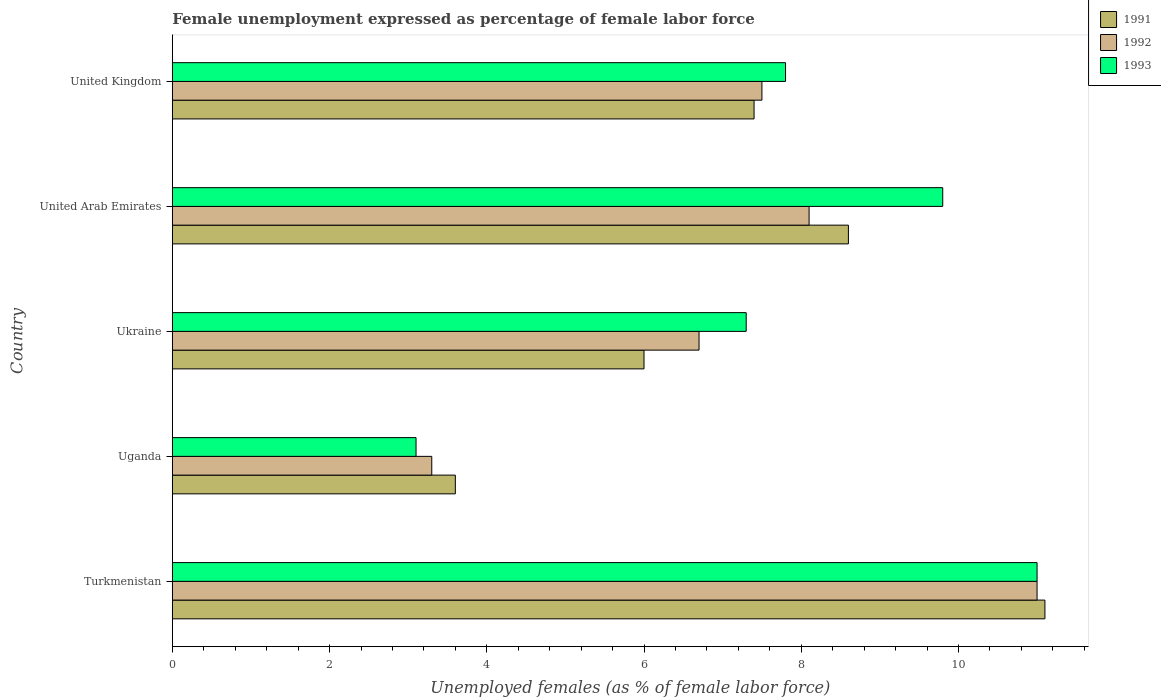How many different coloured bars are there?
Offer a terse response. 3. How many groups of bars are there?
Give a very brief answer. 5. Are the number of bars per tick equal to the number of legend labels?
Give a very brief answer. Yes. How many bars are there on the 5th tick from the top?
Keep it short and to the point. 3. How many bars are there on the 3rd tick from the bottom?
Provide a short and direct response. 3. What is the label of the 5th group of bars from the top?
Offer a terse response. Turkmenistan. In how many cases, is the number of bars for a given country not equal to the number of legend labels?
Keep it short and to the point. 0. What is the unemployment in females in in 1993 in Uganda?
Your answer should be very brief. 3.1. Across all countries, what is the maximum unemployment in females in in 1992?
Your answer should be compact. 11. Across all countries, what is the minimum unemployment in females in in 1992?
Provide a short and direct response. 3.3. In which country was the unemployment in females in in 1991 maximum?
Your answer should be compact. Turkmenistan. In which country was the unemployment in females in in 1993 minimum?
Provide a succinct answer. Uganda. What is the total unemployment in females in in 1992 in the graph?
Keep it short and to the point. 36.6. What is the difference between the unemployment in females in in 1991 in Uganda and that in United Kingdom?
Keep it short and to the point. -3.8. What is the difference between the unemployment in females in in 1993 in Uganda and the unemployment in females in in 1992 in Turkmenistan?
Offer a very short reply. -7.9. What is the average unemployment in females in in 1992 per country?
Offer a terse response. 7.32. What is the difference between the unemployment in females in in 1993 and unemployment in females in in 1992 in United Kingdom?
Your answer should be very brief. 0.3. What is the ratio of the unemployment in females in in 1993 in Uganda to that in United Kingdom?
Keep it short and to the point. 0.4. Is the unemployment in females in in 1991 in United Arab Emirates less than that in United Kingdom?
Your response must be concise. No. Is the difference between the unemployment in females in in 1993 in United Arab Emirates and United Kingdom greater than the difference between the unemployment in females in in 1992 in United Arab Emirates and United Kingdom?
Make the answer very short. Yes. What is the difference between the highest and the second highest unemployment in females in in 1991?
Offer a terse response. 2.5. What is the difference between the highest and the lowest unemployment in females in in 1993?
Your answer should be very brief. 7.9. Is the sum of the unemployment in females in in 1992 in Uganda and United Arab Emirates greater than the maximum unemployment in females in in 1991 across all countries?
Offer a terse response. Yes. What does the 1st bar from the bottom in Turkmenistan represents?
Your answer should be very brief. 1991. Is it the case that in every country, the sum of the unemployment in females in in 1993 and unemployment in females in in 1992 is greater than the unemployment in females in in 1991?
Your answer should be very brief. Yes. How many bars are there?
Make the answer very short. 15. How many countries are there in the graph?
Ensure brevity in your answer.  5. What is the difference between two consecutive major ticks on the X-axis?
Your response must be concise. 2. Are the values on the major ticks of X-axis written in scientific E-notation?
Provide a short and direct response. No. Does the graph contain any zero values?
Provide a succinct answer. No. What is the title of the graph?
Offer a terse response. Female unemployment expressed as percentage of female labor force. Does "1986" appear as one of the legend labels in the graph?
Offer a terse response. No. What is the label or title of the X-axis?
Your response must be concise. Unemployed females (as % of female labor force). What is the label or title of the Y-axis?
Ensure brevity in your answer.  Country. What is the Unemployed females (as % of female labor force) in 1991 in Turkmenistan?
Offer a very short reply. 11.1. What is the Unemployed females (as % of female labor force) in 1991 in Uganda?
Offer a very short reply. 3.6. What is the Unemployed females (as % of female labor force) of 1992 in Uganda?
Keep it short and to the point. 3.3. What is the Unemployed females (as % of female labor force) of 1993 in Uganda?
Make the answer very short. 3.1. What is the Unemployed females (as % of female labor force) of 1991 in Ukraine?
Ensure brevity in your answer.  6. What is the Unemployed females (as % of female labor force) of 1992 in Ukraine?
Provide a short and direct response. 6.7. What is the Unemployed females (as % of female labor force) in 1993 in Ukraine?
Offer a very short reply. 7.3. What is the Unemployed females (as % of female labor force) in 1991 in United Arab Emirates?
Make the answer very short. 8.6. What is the Unemployed females (as % of female labor force) of 1992 in United Arab Emirates?
Ensure brevity in your answer.  8.1. What is the Unemployed females (as % of female labor force) of 1993 in United Arab Emirates?
Make the answer very short. 9.8. What is the Unemployed females (as % of female labor force) in 1991 in United Kingdom?
Make the answer very short. 7.4. What is the Unemployed females (as % of female labor force) of 1992 in United Kingdom?
Make the answer very short. 7.5. What is the Unemployed females (as % of female labor force) of 1993 in United Kingdom?
Provide a short and direct response. 7.8. Across all countries, what is the maximum Unemployed females (as % of female labor force) in 1991?
Keep it short and to the point. 11.1. Across all countries, what is the minimum Unemployed females (as % of female labor force) in 1991?
Your answer should be compact. 3.6. Across all countries, what is the minimum Unemployed females (as % of female labor force) in 1992?
Your response must be concise. 3.3. Across all countries, what is the minimum Unemployed females (as % of female labor force) of 1993?
Your answer should be compact. 3.1. What is the total Unemployed females (as % of female labor force) of 1991 in the graph?
Ensure brevity in your answer.  36.7. What is the total Unemployed females (as % of female labor force) of 1992 in the graph?
Give a very brief answer. 36.6. What is the total Unemployed females (as % of female labor force) in 1993 in the graph?
Give a very brief answer. 39. What is the difference between the Unemployed females (as % of female labor force) of 1991 in Turkmenistan and that in Uganda?
Give a very brief answer. 7.5. What is the difference between the Unemployed females (as % of female labor force) of 1993 in Turkmenistan and that in Uganda?
Give a very brief answer. 7.9. What is the difference between the Unemployed females (as % of female labor force) of 1992 in Turkmenistan and that in Ukraine?
Provide a short and direct response. 4.3. What is the difference between the Unemployed females (as % of female labor force) in 1993 in Turkmenistan and that in Ukraine?
Keep it short and to the point. 3.7. What is the difference between the Unemployed females (as % of female labor force) of 1991 in Turkmenistan and that in United Arab Emirates?
Keep it short and to the point. 2.5. What is the difference between the Unemployed females (as % of female labor force) of 1992 in Turkmenistan and that in United Arab Emirates?
Offer a very short reply. 2.9. What is the difference between the Unemployed females (as % of female labor force) of 1993 in Turkmenistan and that in United Arab Emirates?
Keep it short and to the point. 1.2. What is the difference between the Unemployed females (as % of female labor force) in 1992 in Turkmenistan and that in United Kingdom?
Your answer should be very brief. 3.5. What is the difference between the Unemployed females (as % of female labor force) in 1991 in Uganda and that in Ukraine?
Offer a very short reply. -2.4. What is the difference between the Unemployed females (as % of female labor force) of 1992 in Uganda and that in Ukraine?
Make the answer very short. -3.4. What is the difference between the Unemployed females (as % of female labor force) of 1992 in Uganda and that in United Kingdom?
Your response must be concise. -4.2. What is the difference between the Unemployed females (as % of female labor force) of 1993 in Uganda and that in United Kingdom?
Offer a terse response. -4.7. What is the difference between the Unemployed females (as % of female labor force) in 1991 in Ukraine and that in United Kingdom?
Offer a terse response. -1.4. What is the difference between the Unemployed females (as % of female labor force) of 1993 in United Arab Emirates and that in United Kingdom?
Provide a succinct answer. 2. What is the difference between the Unemployed females (as % of female labor force) of 1991 in Turkmenistan and the Unemployed females (as % of female labor force) of 1993 in Uganda?
Your answer should be compact. 8. What is the difference between the Unemployed females (as % of female labor force) in 1992 in Turkmenistan and the Unemployed females (as % of female labor force) in 1993 in Uganda?
Keep it short and to the point. 7.9. What is the difference between the Unemployed females (as % of female labor force) of 1991 in Turkmenistan and the Unemployed females (as % of female labor force) of 1992 in Ukraine?
Your answer should be very brief. 4.4. What is the difference between the Unemployed females (as % of female labor force) in 1992 in Turkmenistan and the Unemployed females (as % of female labor force) in 1993 in Ukraine?
Provide a succinct answer. 3.7. What is the difference between the Unemployed females (as % of female labor force) in 1991 in Turkmenistan and the Unemployed females (as % of female labor force) in 1992 in United Arab Emirates?
Offer a terse response. 3. What is the difference between the Unemployed females (as % of female labor force) of 1991 in Turkmenistan and the Unemployed females (as % of female labor force) of 1993 in United Arab Emirates?
Provide a succinct answer. 1.3. What is the difference between the Unemployed females (as % of female labor force) of 1992 in Turkmenistan and the Unemployed females (as % of female labor force) of 1993 in United Arab Emirates?
Your answer should be very brief. 1.2. What is the difference between the Unemployed females (as % of female labor force) in 1991 in Turkmenistan and the Unemployed females (as % of female labor force) in 1993 in United Kingdom?
Offer a terse response. 3.3. What is the difference between the Unemployed females (as % of female labor force) of 1992 in Turkmenistan and the Unemployed females (as % of female labor force) of 1993 in United Kingdom?
Your response must be concise. 3.2. What is the difference between the Unemployed females (as % of female labor force) of 1991 in Uganda and the Unemployed females (as % of female labor force) of 1992 in Ukraine?
Keep it short and to the point. -3.1. What is the difference between the Unemployed females (as % of female labor force) of 1991 in Uganda and the Unemployed females (as % of female labor force) of 1993 in United Arab Emirates?
Your response must be concise. -6.2. What is the difference between the Unemployed females (as % of female labor force) of 1991 in Uganda and the Unemployed females (as % of female labor force) of 1992 in United Kingdom?
Keep it short and to the point. -3.9. What is the difference between the Unemployed females (as % of female labor force) of 1991 in Uganda and the Unemployed females (as % of female labor force) of 1993 in United Kingdom?
Your answer should be very brief. -4.2. What is the difference between the Unemployed females (as % of female labor force) of 1991 in Ukraine and the Unemployed females (as % of female labor force) of 1992 in United Arab Emirates?
Make the answer very short. -2.1. What is the difference between the Unemployed females (as % of female labor force) in 1992 in Ukraine and the Unemployed females (as % of female labor force) in 1993 in United Kingdom?
Give a very brief answer. -1.1. What is the difference between the Unemployed females (as % of female labor force) of 1991 in United Arab Emirates and the Unemployed females (as % of female labor force) of 1992 in United Kingdom?
Provide a short and direct response. 1.1. What is the average Unemployed females (as % of female labor force) in 1991 per country?
Ensure brevity in your answer.  7.34. What is the average Unemployed females (as % of female labor force) in 1992 per country?
Provide a short and direct response. 7.32. What is the difference between the Unemployed females (as % of female labor force) of 1991 and Unemployed females (as % of female labor force) of 1993 in Turkmenistan?
Provide a short and direct response. 0.1. What is the difference between the Unemployed females (as % of female labor force) of 1992 and Unemployed females (as % of female labor force) of 1993 in Turkmenistan?
Offer a terse response. 0. What is the difference between the Unemployed females (as % of female labor force) in 1991 and Unemployed females (as % of female labor force) in 1992 in Uganda?
Keep it short and to the point. 0.3. What is the difference between the Unemployed females (as % of female labor force) of 1992 and Unemployed females (as % of female labor force) of 1993 in Uganda?
Offer a terse response. 0.2. What is the difference between the Unemployed females (as % of female labor force) in 1991 and Unemployed females (as % of female labor force) in 1992 in Ukraine?
Make the answer very short. -0.7. What is the difference between the Unemployed females (as % of female labor force) of 1991 and Unemployed females (as % of female labor force) of 1993 in Ukraine?
Give a very brief answer. -1.3. What is the difference between the Unemployed females (as % of female labor force) in 1992 and Unemployed females (as % of female labor force) in 1993 in Ukraine?
Make the answer very short. -0.6. What is the difference between the Unemployed females (as % of female labor force) in 1991 and Unemployed females (as % of female labor force) in 1992 in United Arab Emirates?
Your answer should be very brief. 0.5. What is the difference between the Unemployed females (as % of female labor force) in 1991 and Unemployed females (as % of female labor force) in 1993 in United Arab Emirates?
Give a very brief answer. -1.2. What is the difference between the Unemployed females (as % of female labor force) in 1991 and Unemployed females (as % of female labor force) in 1992 in United Kingdom?
Provide a short and direct response. -0.1. What is the difference between the Unemployed females (as % of female labor force) in 1992 and Unemployed females (as % of female labor force) in 1993 in United Kingdom?
Ensure brevity in your answer.  -0.3. What is the ratio of the Unemployed females (as % of female labor force) of 1991 in Turkmenistan to that in Uganda?
Ensure brevity in your answer.  3.08. What is the ratio of the Unemployed females (as % of female labor force) of 1992 in Turkmenistan to that in Uganda?
Your response must be concise. 3.33. What is the ratio of the Unemployed females (as % of female labor force) in 1993 in Turkmenistan to that in Uganda?
Your answer should be compact. 3.55. What is the ratio of the Unemployed females (as % of female labor force) of 1991 in Turkmenistan to that in Ukraine?
Provide a succinct answer. 1.85. What is the ratio of the Unemployed females (as % of female labor force) in 1992 in Turkmenistan to that in Ukraine?
Provide a succinct answer. 1.64. What is the ratio of the Unemployed females (as % of female labor force) in 1993 in Turkmenistan to that in Ukraine?
Provide a succinct answer. 1.51. What is the ratio of the Unemployed females (as % of female labor force) of 1991 in Turkmenistan to that in United Arab Emirates?
Provide a succinct answer. 1.29. What is the ratio of the Unemployed females (as % of female labor force) in 1992 in Turkmenistan to that in United Arab Emirates?
Provide a succinct answer. 1.36. What is the ratio of the Unemployed females (as % of female labor force) in 1993 in Turkmenistan to that in United Arab Emirates?
Your answer should be compact. 1.12. What is the ratio of the Unemployed females (as % of female labor force) of 1991 in Turkmenistan to that in United Kingdom?
Provide a short and direct response. 1.5. What is the ratio of the Unemployed females (as % of female labor force) of 1992 in Turkmenistan to that in United Kingdom?
Provide a succinct answer. 1.47. What is the ratio of the Unemployed females (as % of female labor force) in 1993 in Turkmenistan to that in United Kingdom?
Your answer should be very brief. 1.41. What is the ratio of the Unemployed females (as % of female labor force) in 1991 in Uganda to that in Ukraine?
Offer a terse response. 0.6. What is the ratio of the Unemployed females (as % of female labor force) of 1992 in Uganda to that in Ukraine?
Offer a very short reply. 0.49. What is the ratio of the Unemployed females (as % of female labor force) of 1993 in Uganda to that in Ukraine?
Offer a very short reply. 0.42. What is the ratio of the Unemployed females (as % of female labor force) of 1991 in Uganda to that in United Arab Emirates?
Your response must be concise. 0.42. What is the ratio of the Unemployed females (as % of female labor force) in 1992 in Uganda to that in United Arab Emirates?
Provide a short and direct response. 0.41. What is the ratio of the Unemployed females (as % of female labor force) in 1993 in Uganda to that in United Arab Emirates?
Keep it short and to the point. 0.32. What is the ratio of the Unemployed females (as % of female labor force) in 1991 in Uganda to that in United Kingdom?
Give a very brief answer. 0.49. What is the ratio of the Unemployed females (as % of female labor force) in 1992 in Uganda to that in United Kingdom?
Ensure brevity in your answer.  0.44. What is the ratio of the Unemployed females (as % of female labor force) of 1993 in Uganda to that in United Kingdom?
Offer a terse response. 0.4. What is the ratio of the Unemployed females (as % of female labor force) in 1991 in Ukraine to that in United Arab Emirates?
Provide a succinct answer. 0.7. What is the ratio of the Unemployed females (as % of female labor force) of 1992 in Ukraine to that in United Arab Emirates?
Ensure brevity in your answer.  0.83. What is the ratio of the Unemployed females (as % of female labor force) in 1993 in Ukraine to that in United Arab Emirates?
Offer a terse response. 0.74. What is the ratio of the Unemployed females (as % of female labor force) of 1991 in Ukraine to that in United Kingdom?
Your response must be concise. 0.81. What is the ratio of the Unemployed females (as % of female labor force) in 1992 in Ukraine to that in United Kingdom?
Keep it short and to the point. 0.89. What is the ratio of the Unemployed females (as % of female labor force) in 1993 in Ukraine to that in United Kingdom?
Make the answer very short. 0.94. What is the ratio of the Unemployed females (as % of female labor force) of 1991 in United Arab Emirates to that in United Kingdom?
Ensure brevity in your answer.  1.16. What is the ratio of the Unemployed females (as % of female labor force) in 1993 in United Arab Emirates to that in United Kingdom?
Offer a very short reply. 1.26. What is the difference between the highest and the second highest Unemployed females (as % of female labor force) of 1993?
Your answer should be compact. 1.2. What is the difference between the highest and the lowest Unemployed females (as % of female labor force) of 1993?
Your response must be concise. 7.9. 